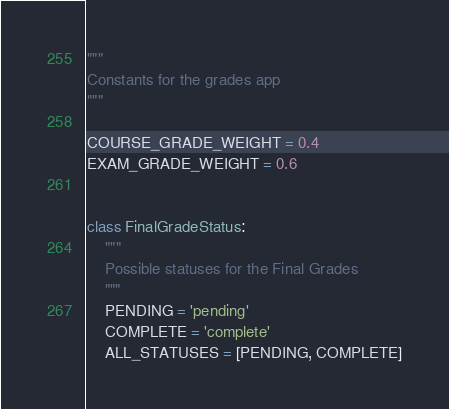Convert code to text. <code><loc_0><loc_0><loc_500><loc_500><_Python_>"""
Constants for the grades app
"""

COURSE_GRADE_WEIGHT = 0.4
EXAM_GRADE_WEIGHT = 0.6


class FinalGradeStatus:
    """
    Possible statuses for the Final Grades
    """
    PENDING = 'pending'
    COMPLETE = 'complete'
    ALL_STATUSES = [PENDING, COMPLETE]
</code> 